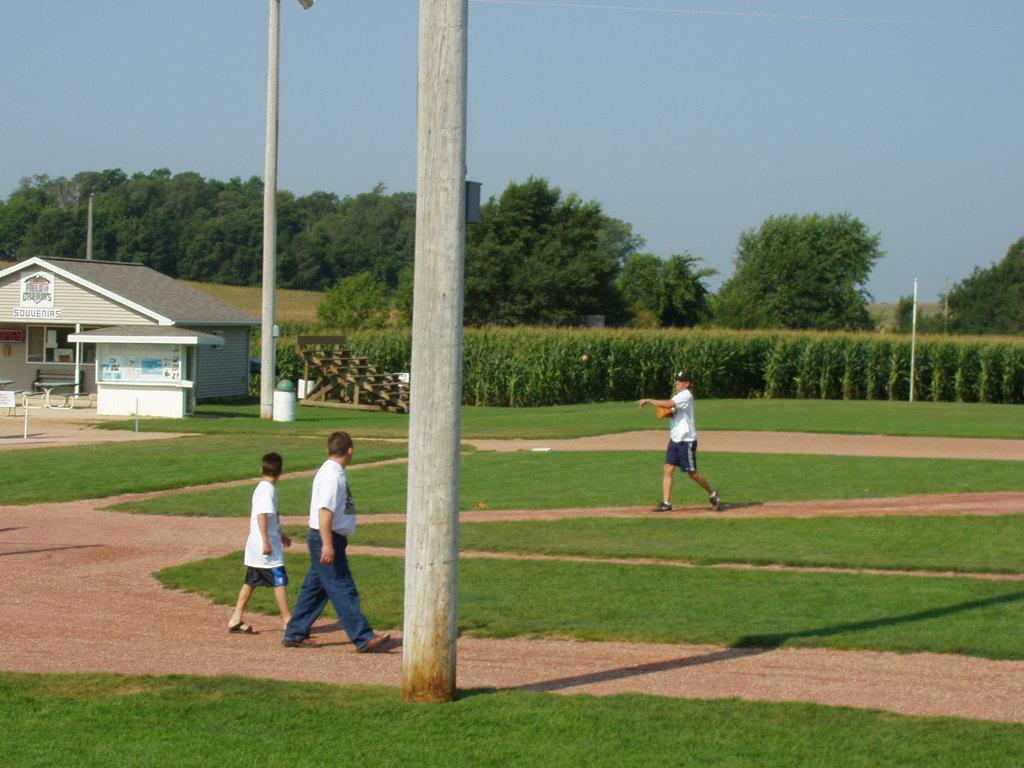What are the people in the image doing? The people in the image are walking on the ground. What structures can be seen in the image? Poles and at least one building are visible in the image. What type of landscape is present in the image? An agricultural farm and trees are visible in the image. What part of the natural environment is visible in the image? The sky is visible in the image. How many seats are available for the people in the image? There is no mention of seats in the image, so it is impossible to determine the number of available seats. What is the cause of death for the person in the image? There is no person in the image who appears to be deceased, so it is impossible to determine the cause of death. 